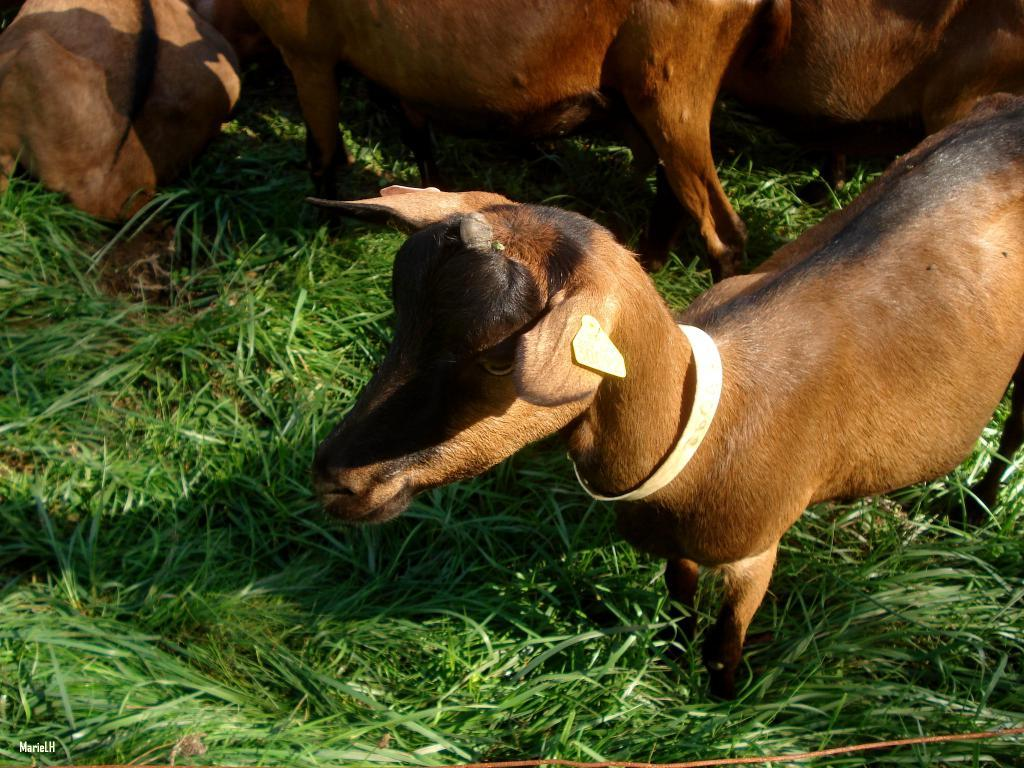What is the main subject of the image? The main subject of the image is a herd. Where are the animals in the herd located? The herd is standing on the grass. What type of disease is affecting the herd in the image? There is no indication of any disease affecting the herd in the image. Is the herd involved in a war in the image? There is no indication of any war or conflict involving the herd in the image. 